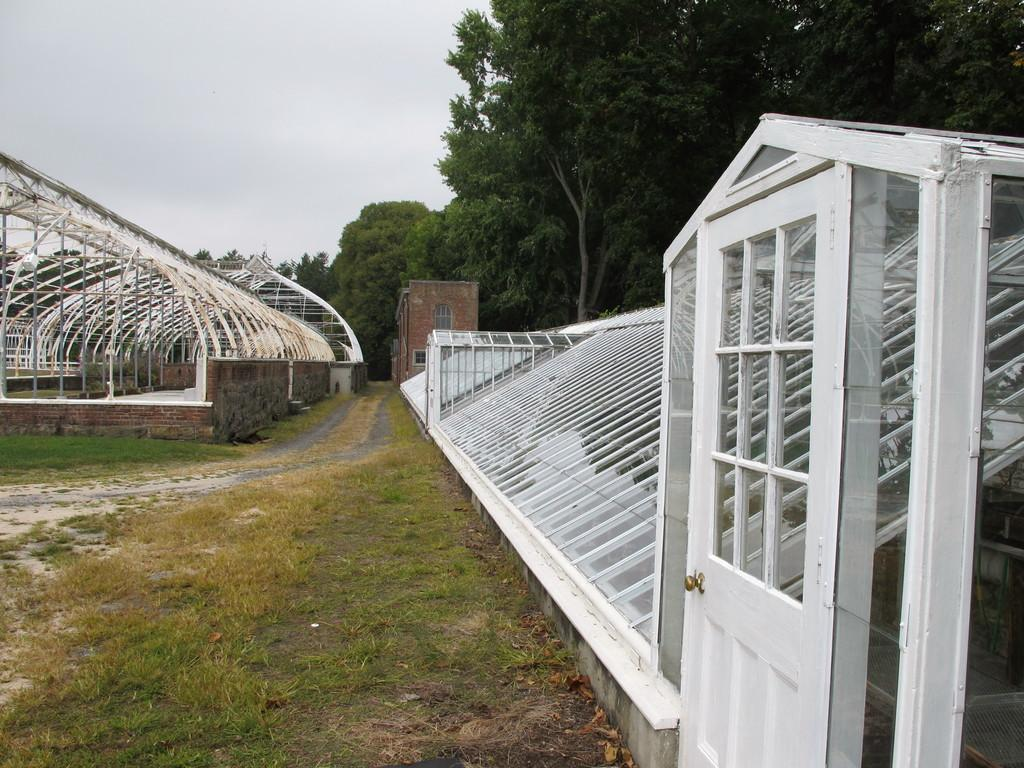What type of vegetation can be seen in the image? There is grass in the image. What kind of feature is present for walking or traversing the area? There is a path in the image. What type of structures are visible in the image? There are sheds and a building in the image. What other natural elements can be seen in the image? There are trees in the image. What is visible in the background of the image? The sky is visible in the background of the image. Can you tell me how many stamps are on the building in the image? There are no stamps present on the building in the image. What type of beef is being served in the image? There is no beef present in the image. 